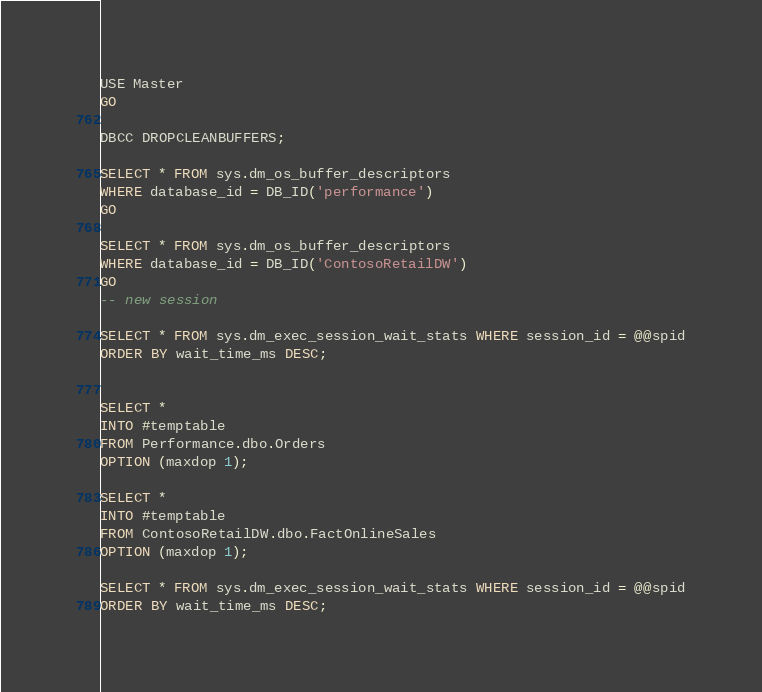Convert code to text. <code><loc_0><loc_0><loc_500><loc_500><_SQL_>USE Master
GO

DBCC DROPCLEANBUFFERS;

SELECT * FROM sys.dm_os_buffer_descriptors
WHERE database_id = DB_ID('performance')
GO

SELECT * FROM sys.dm_os_buffer_descriptors
WHERE database_id = DB_ID('ContosoRetailDW')
GO
-- new session 

SELECT * FROM sys.dm_exec_session_wait_stats WHERE session_id = @@spid
ORDER BY wait_time_ms DESC;


SELECT *
INTO #temptable
FROM Performance.dbo.Orders
OPTION (maxdop 1);

SELECT *
INTO #temptable
FROM ContosoRetailDW.dbo.FactOnlineSales
OPTION (maxdop 1);

SELECT * FROM sys.dm_exec_session_wait_stats WHERE session_id = @@spid
ORDER BY wait_time_ms DESC;</code> 